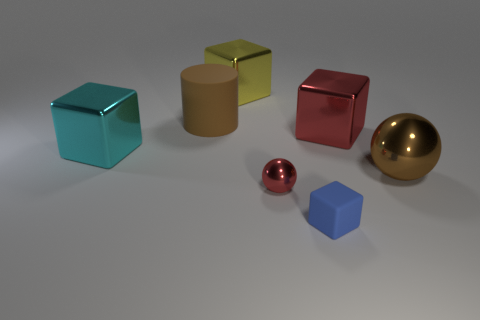Add 2 big things. How many objects exist? 9 Subtract all balls. How many objects are left? 5 Add 7 big yellow objects. How many big yellow objects are left? 8 Add 4 small cyan rubber cubes. How many small cyan rubber cubes exist? 4 Subtract 0 brown cubes. How many objects are left? 7 Subtract all large yellow metallic cubes. Subtract all small green matte cubes. How many objects are left? 6 